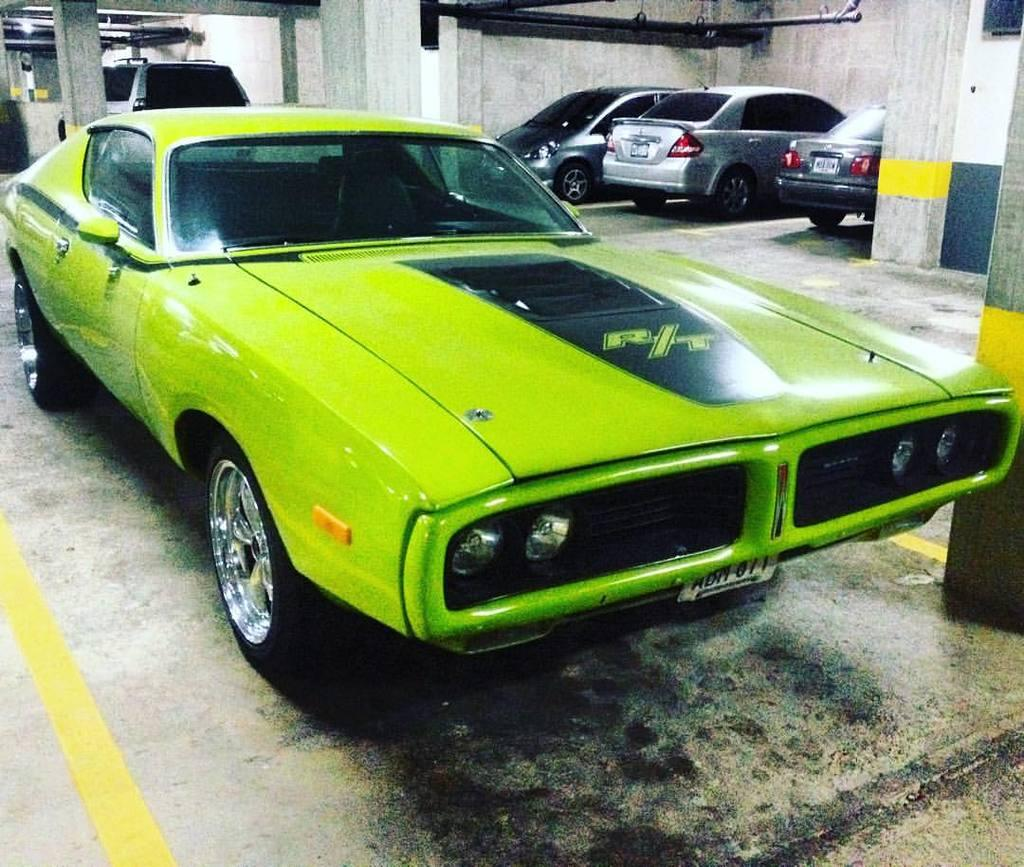What types of objects can be seen in the image? There are vehicles and pillars in the image. Can you describe any specific features of the vehicles? Yes, there is text on one of the vehicles. What is the base of the image made of? There is a floor at the bottom of the image. Is there any source of light visible in the image? Yes, there is a light on the roof. Can you see an arch in the image? There is no arch present in the image. Is there a swing visible in the image? There is no swing present in the image. 